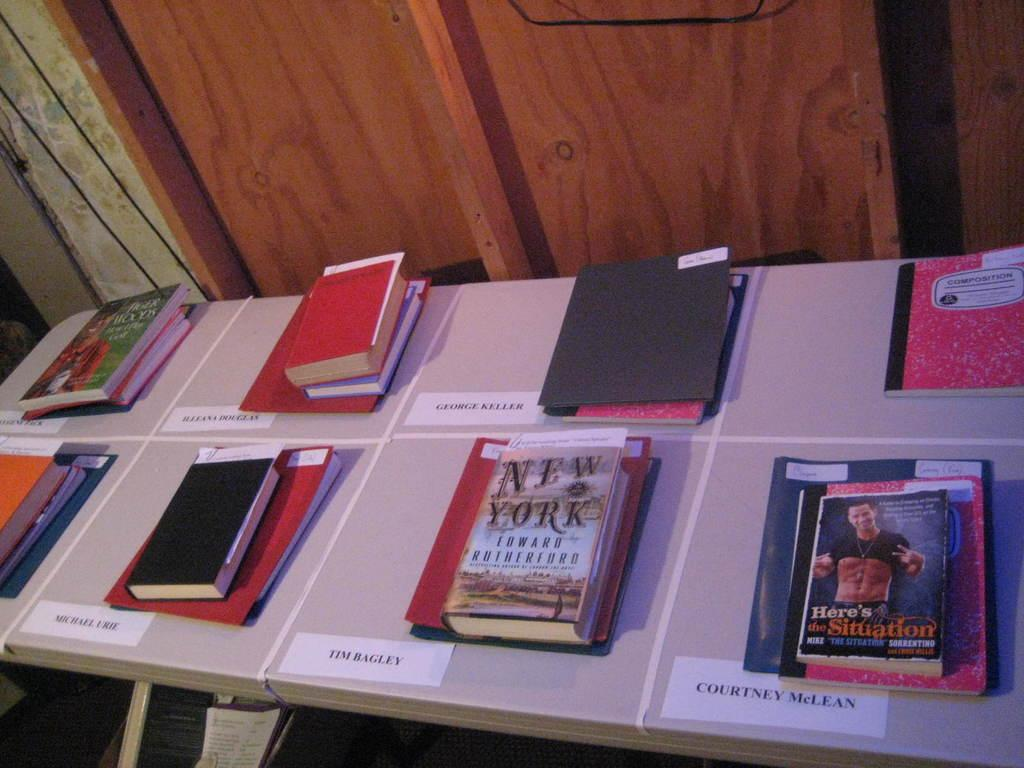<image>
Create a compact narrative representing the image presented. A book titled "New York" by Edward Rutherfurd. 